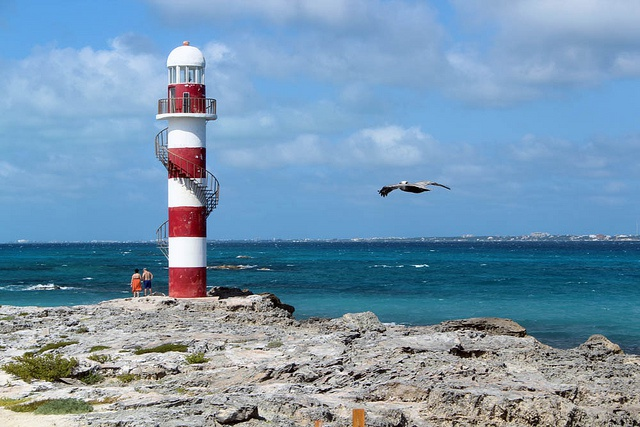Describe the objects in this image and their specific colors. I can see bird in gray, black, and darkgray tones, people in gray, salmon, lightpink, brown, and red tones, and people in gray, black, and navy tones in this image. 